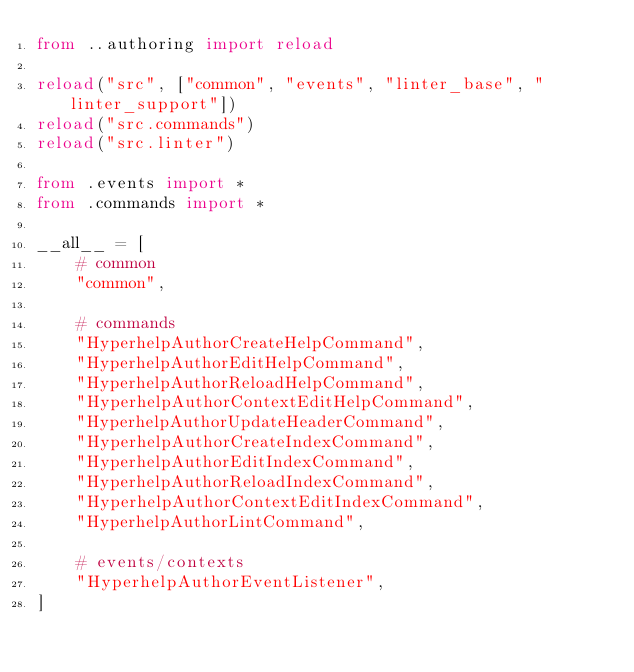Convert code to text. <code><loc_0><loc_0><loc_500><loc_500><_Python_>from ..authoring import reload

reload("src", ["common", "events", "linter_base", "linter_support"])
reload("src.commands")
reload("src.linter")

from .events import *
from .commands import *

__all__ = [
    # common
    "common",

    # commands
    "HyperhelpAuthorCreateHelpCommand",
    "HyperhelpAuthorEditHelpCommand",
    "HyperhelpAuthorReloadHelpCommand",
    "HyperhelpAuthorContextEditHelpCommand",
    "HyperhelpAuthorUpdateHeaderCommand",
    "HyperhelpAuthorCreateIndexCommand",
    "HyperhelpAuthorEditIndexCommand",
    "HyperhelpAuthorReloadIndexCommand",
    "HyperhelpAuthorContextEditIndexCommand",
    "HyperhelpAuthorLintCommand",

    # events/contexts
    "HyperhelpAuthorEventListener",
]
</code> 